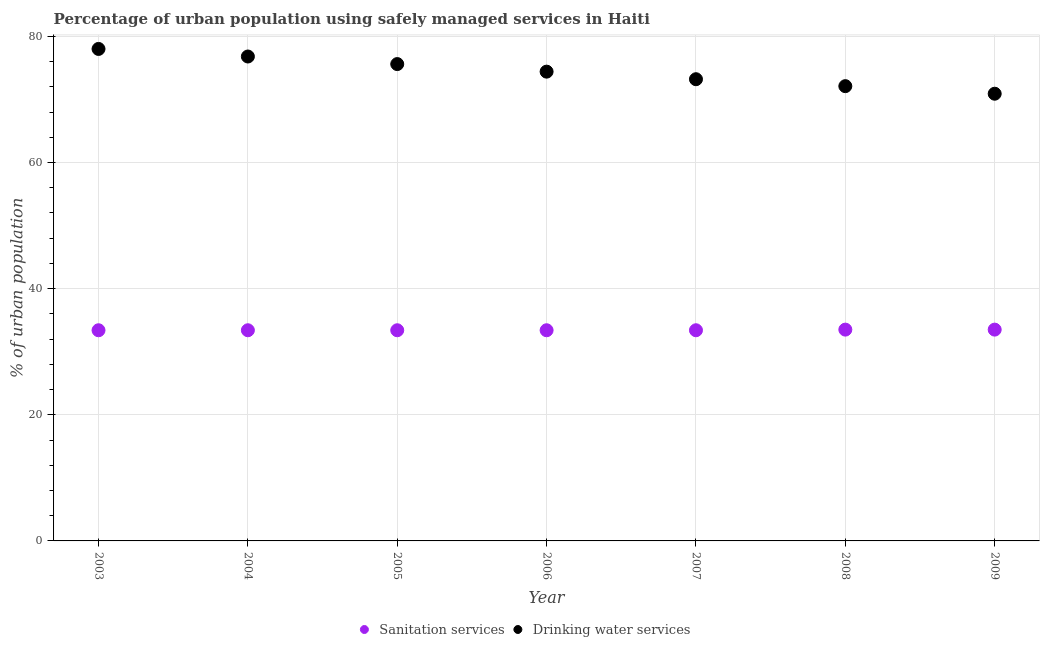Is the number of dotlines equal to the number of legend labels?
Your answer should be compact. Yes. What is the percentage of urban population who used drinking water services in 2006?
Keep it short and to the point. 74.4. Across all years, what is the maximum percentage of urban population who used drinking water services?
Offer a terse response. 78. Across all years, what is the minimum percentage of urban population who used drinking water services?
Provide a short and direct response. 70.9. In which year was the percentage of urban population who used drinking water services minimum?
Keep it short and to the point. 2009. What is the total percentage of urban population who used sanitation services in the graph?
Keep it short and to the point. 234. What is the difference between the percentage of urban population who used drinking water services in 2008 and that in 2009?
Offer a terse response. 1.2. What is the difference between the percentage of urban population who used drinking water services in 2006 and the percentage of urban population who used sanitation services in 2004?
Your response must be concise. 41. What is the average percentage of urban population who used sanitation services per year?
Your response must be concise. 33.43. In the year 2004, what is the difference between the percentage of urban population who used sanitation services and percentage of urban population who used drinking water services?
Offer a terse response. -43.4. What is the ratio of the percentage of urban population who used sanitation services in 2005 to that in 2008?
Give a very brief answer. 1. Is the difference between the percentage of urban population who used sanitation services in 2004 and 2009 greater than the difference between the percentage of urban population who used drinking water services in 2004 and 2009?
Make the answer very short. No. What is the difference between the highest and the second highest percentage of urban population who used drinking water services?
Offer a terse response. 1.2. What is the difference between the highest and the lowest percentage of urban population who used sanitation services?
Offer a very short reply. 0.1. In how many years, is the percentage of urban population who used sanitation services greater than the average percentage of urban population who used sanitation services taken over all years?
Your answer should be very brief. 2. Is the percentage of urban population who used sanitation services strictly greater than the percentage of urban population who used drinking water services over the years?
Keep it short and to the point. No. Is the percentage of urban population who used drinking water services strictly less than the percentage of urban population who used sanitation services over the years?
Your answer should be very brief. No. How many dotlines are there?
Your response must be concise. 2. How many years are there in the graph?
Your answer should be very brief. 7. What is the difference between two consecutive major ticks on the Y-axis?
Provide a short and direct response. 20. Are the values on the major ticks of Y-axis written in scientific E-notation?
Ensure brevity in your answer.  No. Does the graph contain any zero values?
Offer a very short reply. No. Does the graph contain grids?
Provide a short and direct response. Yes. How are the legend labels stacked?
Provide a succinct answer. Horizontal. What is the title of the graph?
Give a very brief answer. Percentage of urban population using safely managed services in Haiti. What is the label or title of the X-axis?
Offer a very short reply. Year. What is the label or title of the Y-axis?
Provide a short and direct response. % of urban population. What is the % of urban population in Sanitation services in 2003?
Provide a succinct answer. 33.4. What is the % of urban population of Sanitation services in 2004?
Your answer should be compact. 33.4. What is the % of urban population in Drinking water services in 2004?
Keep it short and to the point. 76.8. What is the % of urban population of Sanitation services in 2005?
Your response must be concise. 33.4. What is the % of urban population of Drinking water services in 2005?
Your answer should be compact. 75.6. What is the % of urban population in Sanitation services in 2006?
Offer a very short reply. 33.4. What is the % of urban population of Drinking water services in 2006?
Your answer should be very brief. 74.4. What is the % of urban population of Sanitation services in 2007?
Offer a very short reply. 33.4. What is the % of urban population of Drinking water services in 2007?
Keep it short and to the point. 73.2. What is the % of urban population in Sanitation services in 2008?
Your answer should be compact. 33.5. What is the % of urban population in Drinking water services in 2008?
Your response must be concise. 72.1. What is the % of urban population of Sanitation services in 2009?
Your answer should be compact. 33.5. What is the % of urban population in Drinking water services in 2009?
Provide a succinct answer. 70.9. Across all years, what is the maximum % of urban population of Sanitation services?
Make the answer very short. 33.5. Across all years, what is the maximum % of urban population in Drinking water services?
Make the answer very short. 78. Across all years, what is the minimum % of urban population of Sanitation services?
Ensure brevity in your answer.  33.4. Across all years, what is the minimum % of urban population of Drinking water services?
Keep it short and to the point. 70.9. What is the total % of urban population of Sanitation services in the graph?
Ensure brevity in your answer.  234. What is the total % of urban population of Drinking water services in the graph?
Offer a very short reply. 521. What is the difference between the % of urban population of Drinking water services in 2003 and that in 2004?
Make the answer very short. 1.2. What is the difference between the % of urban population of Sanitation services in 2003 and that in 2005?
Offer a terse response. 0. What is the difference between the % of urban population of Drinking water services in 2003 and that in 2005?
Your response must be concise. 2.4. What is the difference between the % of urban population of Drinking water services in 2003 and that in 2006?
Your answer should be compact. 3.6. What is the difference between the % of urban population in Drinking water services in 2003 and that in 2007?
Provide a short and direct response. 4.8. What is the difference between the % of urban population in Sanitation services in 2003 and that in 2008?
Your response must be concise. -0.1. What is the difference between the % of urban population of Sanitation services in 2003 and that in 2009?
Provide a short and direct response. -0.1. What is the difference between the % of urban population in Sanitation services in 2004 and that in 2006?
Offer a terse response. 0. What is the difference between the % of urban population of Drinking water services in 2004 and that in 2006?
Provide a succinct answer. 2.4. What is the difference between the % of urban population of Sanitation services in 2004 and that in 2007?
Offer a very short reply. 0. What is the difference between the % of urban population of Drinking water services in 2004 and that in 2007?
Provide a short and direct response. 3.6. What is the difference between the % of urban population of Sanitation services in 2004 and that in 2009?
Your answer should be compact. -0.1. What is the difference between the % of urban population in Sanitation services in 2005 and that in 2006?
Provide a short and direct response. 0. What is the difference between the % of urban population of Sanitation services in 2005 and that in 2008?
Make the answer very short. -0.1. What is the difference between the % of urban population in Sanitation services in 2005 and that in 2009?
Keep it short and to the point. -0.1. What is the difference between the % of urban population of Drinking water services in 2005 and that in 2009?
Ensure brevity in your answer.  4.7. What is the difference between the % of urban population of Drinking water services in 2006 and that in 2008?
Your response must be concise. 2.3. What is the difference between the % of urban population of Drinking water services in 2007 and that in 2008?
Make the answer very short. 1.1. What is the difference between the % of urban population of Sanitation services in 2008 and that in 2009?
Your answer should be very brief. 0. What is the difference between the % of urban population of Drinking water services in 2008 and that in 2009?
Keep it short and to the point. 1.2. What is the difference between the % of urban population in Sanitation services in 2003 and the % of urban population in Drinking water services in 2004?
Offer a terse response. -43.4. What is the difference between the % of urban population of Sanitation services in 2003 and the % of urban population of Drinking water services in 2005?
Provide a succinct answer. -42.2. What is the difference between the % of urban population of Sanitation services in 2003 and the % of urban population of Drinking water services in 2006?
Your answer should be very brief. -41. What is the difference between the % of urban population in Sanitation services in 2003 and the % of urban population in Drinking water services in 2007?
Give a very brief answer. -39.8. What is the difference between the % of urban population of Sanitation services in 2003 and the % of urban population of Drinking water services in 2008?
Your response must be concise. -38.7. What is the difference between the % of urban population in Sanitation services in 2003 and the % of urban population in Drinking water services in 2009?
Offer a very short reply. -37.5. What is the difference between the % of urban population of Sanitation services in 2004 and the % of urban population of Drinking water services in 2005?
Offer a very short reply. -42.2. What is the difference between the % of urban population in Sanitation services in 2004 and the % of urban population in Drinking water services in 2006?
Provide a short and direct response. -41. What is the difference between the % of urban population in Sanitation services in 2004 and the % of urban population in Drinking water services in 2007?
Your response must be concise. -39.8. What is the difference between the % of urban population of Sanitation services in 2004 and the % of urban population of Drinking water services in 2008?
Offer a very short reply. -38.7. What is the difference between the % of urban population of Sanitation services in 2004 and the % of urban population of Drinking water services in 2009?
Give a very brief answer. -37.5. What is the difference between the % of urban population in Sanitation services in 2005 and the % of urban population in Drinking water services in 2006?
Offer a terse response. -41. What is the difference between the % of urban population in Sanitation services in 2005 and the % of urban population in Drinking water services in 2007?
Provide a short and direct response. -39.8. What is the difference between the % of urban population in Sanitation services in 2005 and the % of urban population in Drinking water services in 2008?
Provide a succinct answer. -38.7. What is the difference between the % of urban population in Sanitation services in 2005 and the % of urban population in Drinking water services in 2009?
Provide a short and direct response. -37.5. What is the difference between the % of urban population in Sanitation services in 2006 and the % of urban population in Drinking water services in 2007?
Offer a very short reply. -39.8. What is the difference between the % of urban population of Sanitation services in 2006 and the % of urban population of Drinking water services in 2008?
Provide a succinct answer. -38.7. What is the difference between the % of urban population in Sanitation services in 2006 and the % of urban population in Drinking water services in 2009?
Provide a short and direct response. -37.5. What is the difference between the % of urban population of Sanitation services in 2007 and the % of urban population of Drinking water services in 2008?
Keep it short and to the point. -38.7. What is the difference between the % of urban population in Sanitation services in 2007 and the % of urban population in Drinking water services in 2009?
Your response must be concise. -37.5. What is the difference between the % of urban population in Sanitation services in 2008 and the % of urban population in Drinking water services in 2009?
Your answer should be compact. -37.4. What is the average % of urban population in Sanitation services per year?
Provide a succinct answer. 33.43. What is the average % of urban population in Drinking water services per year?
Make the answer very short. 74.43. In the year 2003, what is the difference between the % of urban population of Sanitation services and % of urban population of Drinking water services?
Offer a very short reply. -44.6. In the year 2004, what is the difference between the % of urban population in Sanitation services and % of urban population in Drinking water services?
Keep it short and to the point. -43.4. In the year 2005, what is the difference between the % of urban population of Sanitation services and % of urban population of Drinking water services?
Your answer should be compact. -42.2. In the year 2006, what is the difference between the % of urban population of Sanitation services and % of urban population of Drinking water services?
Give a very brief answer. -41. In the year 2007, what is the difference between the % of urban population of Sanitation services and % of urban population of Drinking water services?
Ensure brevity in your answer.  -39.8. In the year 2008, what is the difference between the % of urban population of Sanitation services and % of urban population of Drinking water services?
Give a very brief answer. -38.6. In the year 2009, what is the difference between the % of urban population in Sanitation services and % of urban population in Drinking water services?
Make the answer very short. -37.4. What is the ratio of the % of urban population of Drinking water services in 2003 to that in 2004?
Offer a terse response. 1.02. What is the ratio of the % of urban population in Drinking water services in 2003 to that in 2005?
Offer a very short reply. 1.03. What is the ratio of the % of urban population of Drinking water services in 2003 to that in 2006?
Keep it short and to the point. 1.05. What is the ratio of the % of urban population of Sanitation services in 2003 to that in 2007?
Give a very brief answer. 1. What is the ratio of the % of urban population in Drinking water services in 2003 to that in 2007?
Your response must be concise. 1.07. What is the ratio of the % of urban population of Drinking water services in 2003 to that in 2008?
Give a very brief answer. 1.08. What is the ratio of the % of urban population of Drinking water services in 2003 to that in 2009?
Keep it short and to the point. 1.1. What is the ratio of the % of urban population of Sanitation services in 2004 to that in 2005?
Provide a succinct answer. 1. What is the ratio of the % of urban population in Drinking water services in 2004 to that in 2005?
Provide a succinct answer. 1.02. What is the ratio of the % of urban population of Sanitation services in 2004 to that in 2006?
Offer a very short reply. 1. What is the ratio of the % of urban population of Drinking water services in 2004 to that in 2006?
Make the answer very short. 1.03. What is the ratio of the % of urban population of Sanitation services in 2004 to that in 2007?
Make the answer very short. 1. What is the ratio of the % of urban population in Drinking water services in 2004 to that in 2007?
Your answer should be compact. 1.05. What is the ratio of the % of urban population in Drinking water services in 2004 to that in 2008?
Ensure brevity in your answer.  1.07. What is the ratio of the % of urban population of Drinking water services in 2004 to that in 2009?
Give a very brief answer. 1.08. What is the ratio of the % of urban population of Sanitation services in 2005 to that in 2006?
Provide a succinct answer. 1. What is the ratio of the % of urban population of Drinking water services in 2005 to that in 2006?
Your answer should be very brief. 1.02. What is the ratio of the % of urban population in Sanitation services in 2005 to that in 2007?
Offer a terse response. 1. What is the ratio of the % of urban population of Drinking water services in 2005 to that in 2007?
Provide a short and direct response. 1.03. What is the ratio of the % of urban population of Sanitation services in 2005 to that in 2008?
Provide a succinct answer. 1. What is the ratio of the % of urban population of Drinking water services in 2005 to that in 2008?
Offer a terse response. 1.05. What is the ratio of the % of urban population in Sanitation services in 2005 to that in 2009?
Ensure brevity in your answer.  1. What is the ratio of the % of urban population in Drinking water services in 2005 to that in 2009?
Provide a succinct answer. 1.07. What is the ratio of the % of urban population of Sanitation services in 2006 to that in 2007?
Your answer should be compact. 1. What is the ratio of the % of urban population of Drinking water services in 2006 to that in 2007?
Keep it short and to the point. 1.02. What is the ratio of the % of urban population in Sanitation services in 2006 to that in 2008?
Ensure brevity in your answer.  1. What is the ratio of the % of urban population of Drinking water services in 2006 to that in 2008?
Make the answer very short. 1.03. What is the ratio of the % of urban population in Drinking water services in 2006 to that in 2009?
Ensure brevity in your answer.  1.05. What is the ratio of the % of urban population of Drinking water services in 2007 to that in 2008?
Offer a very short reply. 1.02. What is the ratio of the % of urban population of Sanitation services in 2007 to that in 2009?
Give a very brief answer. 1. What is the ratio of the % of urban population of Drinking water services in 2007 to that in 2009?
Provide a succinct answer. 1.03. What is the ratio of the % of urban population of Drinking water services in 2008 to that in 2009?
Your response must be concise. 1.02. What is the difference between the highest and the second highest % of urban population in Drinking water services?
Provide a succinct answer. 1.2. What is the difference between the highest and the lowest % of urban population of Sanitation services?
Provide a succinct answer. 0.1. What is the difference between the highest and the lowest % of urban population of Drinking water services?
Provide a succinct answer. 7.1. 